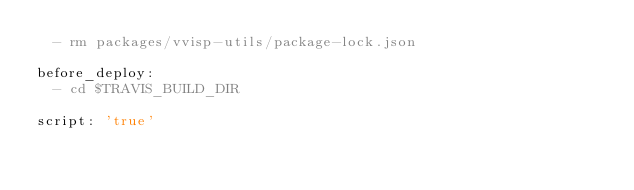<code> <loc_0><loc_0><loc_500><loc_500><_YAML_>  - rm packages/vvisp-utils/package-lock.json

before_deploy:
  - cd $TRAVIS_BUILD_DIR

script: 'true'
</code> 